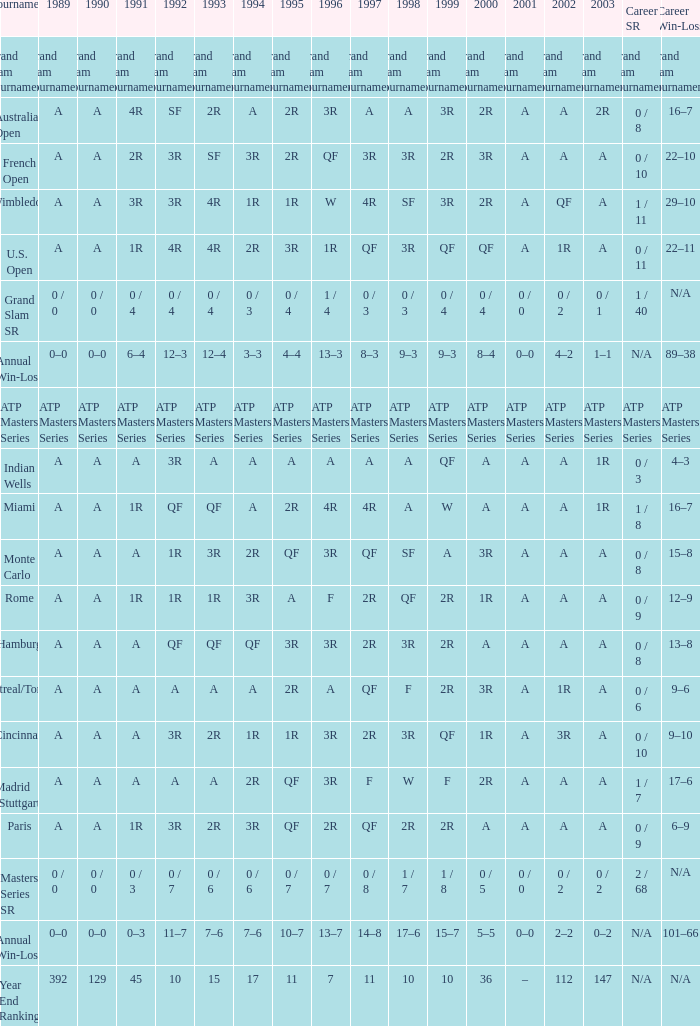I'm looking to parse the entire table for insights. Could you assist me with that? {'header': ['Tournament', '1989', '1990', '1991', '1992', '1993', '1994', '1995', '1996', '1997', '1998', '1999', '2000', '2001', '2002', '2003', 'Career SR', 'Career Win-Loss'], 'rows': [['Grand Slam Tournaments', 'Grand Slam Tournaments', 'Grand Slam Tournaments', 'Grand Slam Tournaments', 'Grand Slam Tournaments', 'Grand Slam Tournaments', 'Grand Slam Tournaments', 'Grand Slam Tournaments', 'Grand Slam Tournaments', 'Grand Slam Tournaments', 'Grand Slam Tournaments', 'Grand Slam Tournaments', 'Grand Slam Tournaments', 'Grand Slam Tournaments', 'Grand Slam Tournaments', 'Grand Slam Tournaments', 'Grand Slam Tournaments', 'Grand Slam Tournaments'], ['Australian Open', 'A', 'A', '4R', 'SF', '2R', 'A', '2R', '3R', 'A', 'A', '3R', '2R', 'A', 'A', '2R', '0 / 8', '16–7'], ['French Open', 'A', 'A', '2R', '3R', 'SF', '3R', '2R', 'QF', '3R', '3R', '2R', '3R', 'A', 'A', 'A', '0 / 10', '22–10'], ['Wimbledon', 'A', 'A', '3R', '3R', '4R', '1R', '1R', 'W', '4R', 'SF', '3R', '2R', 'A', 'QF', 'A', '1 / 11', '29–10'], ['U.S. Open', 'A', 'A', '1R', '4R', '4R', '2R', '3R', '1R', 'QF', '3R', 'QF', 'QF', 'A', '1R', 'A', '0 / 11', '22–11'], ['Grand Slam SR', '0 / 0', '0 / 0', '0 / 4', '0 / 4', '0 / 4', '0 / 3', '0 / 4', '1 / 4', '0 / 3', '0 / 3', '0 / 4', '0 / 4', '0 / 0', '0 / 2', '0 / 1', '1 / 40', 'N/A'], ['Annual Win-Loss', '0–0', '0–0', '6–4', '12–3', '12–4', '3–3', '4–4', '13–3', '8–3', '9–3', '9–3', '8–4', '0–0', '4–2', '1–1', 'N/A', '89–38'], ['ATP Masters Series', 'ATP Masters Series', 'ATP Masters Series', 'ATP Masters Series', 'ATP Masters Series', 'ATP Masters Series', 'ATP Masters Series', 'ATP Masters Series', 'ATP Masters Series', 'ATP Masters Series', 'ATP Masters Series', 'ATP Masters Series', 'ATP Masters Series', 'ATP Masters Series', 'ATP Masters Series', 'ATP Masters Series', 'ATP Masters Series', 'ATP Masters Series'], ['Indian Wells', 'A', 'A', 'A', '3R', 'A', 'A', 'A', 'A', 'A', 'A', 'QF', 'A', 'A', 'A', '1R', '0 / 3', '4–3'], ['Miami', 'A', 'A', '1R', 'QF', 'QF', 'A', '2R', '4R', '4R', 'A', 'W', 'A', 'A', 'A', '1R', '1 / 8', '16–7'], ['Monte Carlo', 'A', 'A', 'A', '1R', '3R', '2R', 'QF', '3R', 'QF', 'SF', 'A', '3R', 'A', 'A', 'A', '0 / 8', '15–8'], ['Rome', 'A', 'A', '1R', '1R', '1R', '3R', 'A', 'F', '2R', 'QF', '2R', '1R', 'A', 'A', 'A', '0 / 9', '12–9'], ['Hamburg', 'A', 'A', 'A', 'QF', 'QF', 'QF', '3R', '3R', '2R', '3R', '2R', 'A', 'A', 'A', 'A', '0 / 8', '13–8'], ['Montreal/Toronto', 'A', 'A', 'A', 'A', 'A', 'A', '2R', 'A', 'QF', 'F', '2R', '3R', 'A', '1R', 'A', '0 / 6', '9–6'], ['Cincinnati', 'A', 'A', 'A', '3R', '2R', '1R', '1R', '3R', '2R', '3R', 'QF', '1R', 'A', '3R', 'A', '0 / 10', '9–10'], ['Madrid (Stuttgart)', 'A', 'A', 'A', 'A', 'A', '2R', 'QF', '3R', 'F', 'W', 'F', '2R', 'A', 'A', 'A', '1 / 7', '17–6'], ['Paris', 'A', 'A', '1R', '3R', '2R', '3R', 'QF', '2R', 'QF', '2R', '2R', 'A', 'A', 'A', 'A', '0 / 9', '6–9'], ['Masters Series SR', '0 / 0', '0 / 0', '0 / 3', '0 / 7', '0 / 6', '0 / 6', '0 / 7', '0 / 7', '0 / 8', '1 / 7', '1 / 8', '0 / 5', '0 / 0', '0 / 2', '0 / 2', '2 / 68', 'N/A'], ['Annual Win-Loss', '0–0', '0–0', '0–3', '11–7', '7–6', '7–6', '10–7', '13–7', '14–8', '17–6', '15–7', '5–5', '0–0', '2–2', '0–2', 'N/A', '101–66'], ['Year End Ranking', '392', '129', '45', '10', '15', '17', '11', '7', '11', '10', '10', '36', '–', '112', '147', 'N/A', 'N/A']]} What is the value in 1997 when the value in 1989 is A, 1995 is QF, 1996 is 3R and the career SR is 0 / 8? QF. 